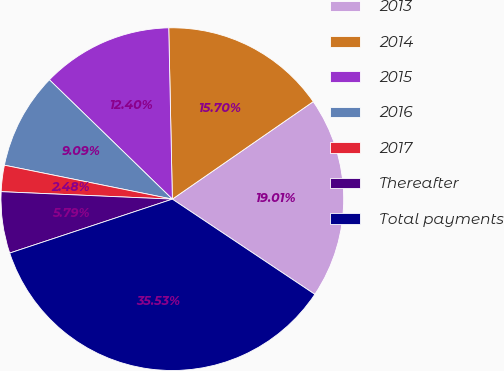Convert chart. <chart><loc_0><loc_0><loc_500><loc_500><pie_chart><fcel>2013<fcel>2014<fcel>2015<fcel>2016<fcel>2017<fcel>Thereafter<fcel>Total payments<nl><fcel>19.01%<fcel>15.7%<fcel>12.4%<fcel>9.09%<fcel>2.48%<fcel>5.79%<fcel>35.53%<nl></chart> 